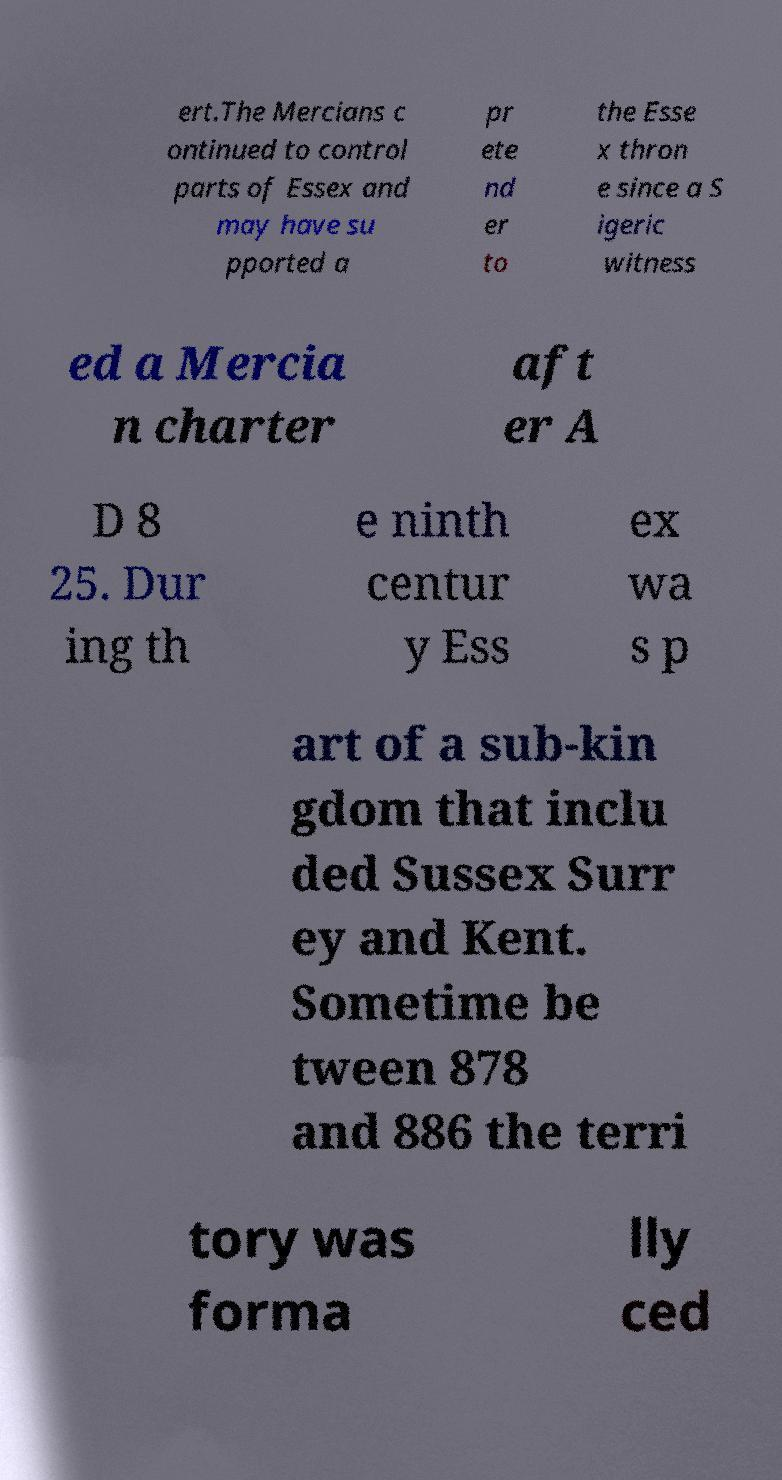Can you accurately transcribe the text from the provided image for me? ert.The Mercians c ontinued to control parts of Essex and may have su pported a pr ete nd er to the Esse x thron e since a S igeric witness ed a Mercia n charter aft er A D 8 25. Dur ing th e ninth centur y Ess ex wa s p art of a sub-kin gdom that inclu ded Sussex Surr ey and Kent. Sometime be tween 878 and 886 the terri tory was forma lly ced 